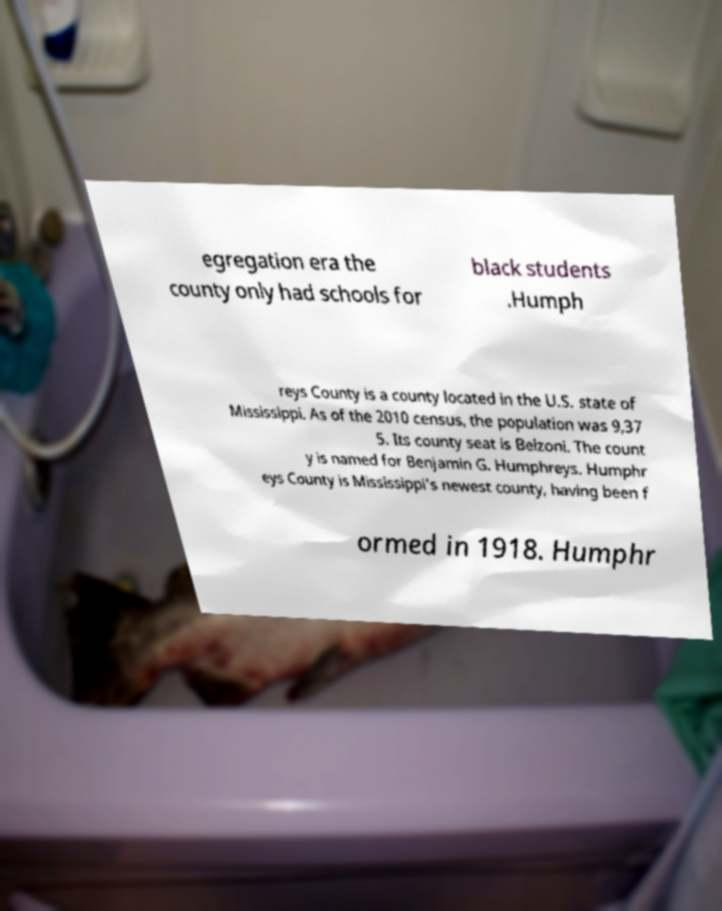I need the written content from this picture converted into text. Can you do that? egregation era the county only had schools for black students .Humph reys County is a county located in the U.S. state of Mississippi. As of the 2010 census, the population was 9,37 5. Its county seat is Belzoni. The count y is named for Benjamin G. Humphreys. Humphr eys County is Mississippi's newest county, having been f ormed in 1918. Humphr 